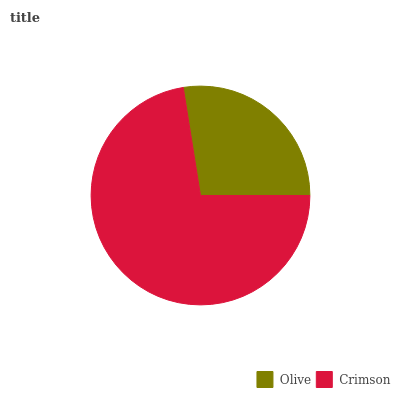Is Olive the minimum?
Answer yes or no. Yes. Is Crimson the maximum?
Answer yes or no. Yes. Is Crimson the minimum?
Answer yes or no. No. Is Crimson greater than Olive?
Answer yes or no. Yes. Is Olive less than Crimson?
Answer yes or no. Yes. Is Olive greater than Crimson?
Answer yes or no. No. Is Crimson less than Olive?
Answer yes or no. No. Is Crimson the high median?
Answer yes or no. Yes. Is Olive the low median?
Answer yes or no. Yes. Is Olive the high median?
Answer yes or no. No. Is Crimson the low median?
Answer yes or no. No. 